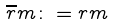Convert formula to latex. <formula><loc_0><loc_0><loc_500><loc_500>\overline { r } m \colon = r m</formula> 